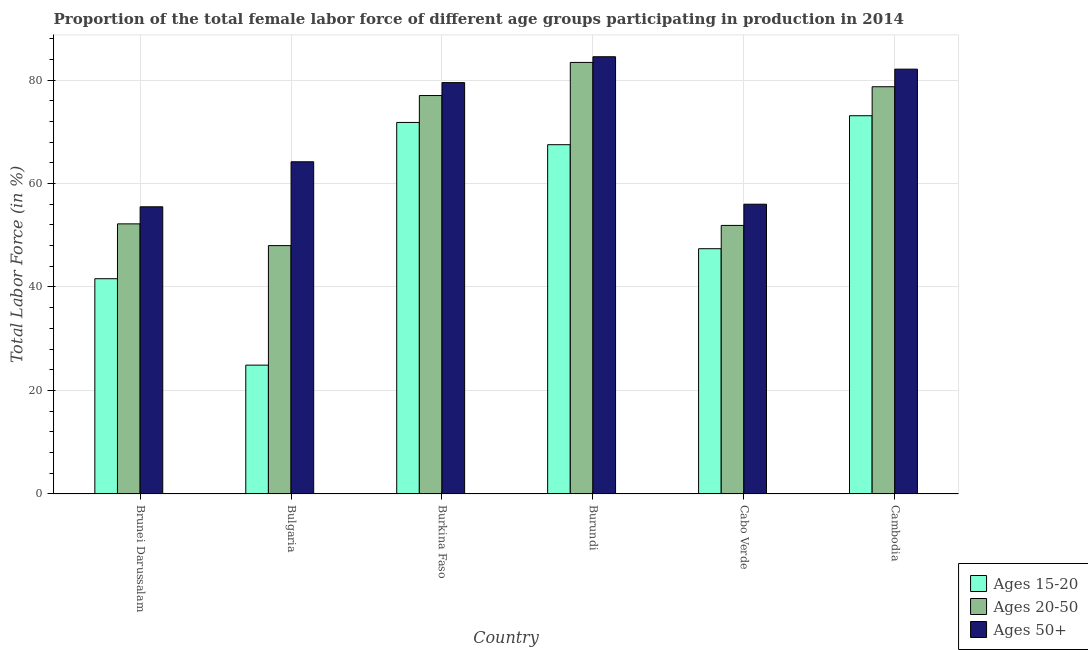How many different coloured bars are there?
Offer a very short reply. 3. Are the number of bars per tick equal to the number of legend labels?
Your response must be concise. Yes. Are the number of bars on each tick of the X-axis equal?
Provide a short and direct response. Yes. How many bars are there on the 6th tick from the left?
Your response must be concise. 3. How many bars are there on the 1st tick from the right?
Keep it short and to the point. 3. In how many cases, is the number of bars for a given country not equal to the number of legend labels?
Provide a succinct answer. 0. What is the percentage of female labor force above age 50 in Brunei Darussalam?
Keep it short and to the point. 55.5. Across all countries, what is the maximum percentage of female labor force within the age group 15-20?
Keep it short and to the point. 73.1. Across all countries, what is the minimum percentage of female labor force within the age group 20-50?
Make the answer very short. 48. In which country was the percentage of female labor force above age 50 maximum?
Keep it short and to the point. Burundi. In which country was the percentage of female labor force within the age group 15-20 minimum?
Offer a very short reply. Bulgaria. What is the total percentage of female labor force above age 50 in the graph?
Provide a succinct answer. 421.8. What is the difference between the percentage of female labor force within the age group 20-50 in Burkina Faso and that in Burundi?
Your answer should be compact. -6.4. What is the difference between the percentage of female labor force within the age group 20-50 in Burkina Faso and the percentage of female labor force within the age group 15-20 in Burundi?
Ensure brevity in your answer.  9.5. What is the average percentage of female labor force within the age group 15-20 per country?
Your answer should be compact. 54.38. What is the ratio of the percentage of female labor force above age 50 in Bulgaria to that in Burkina Faso?
Keep it short and to the point. 0.81. Is the percentage of female labor force above age 50 in Bulgaria less than that in Cambodia?
Ensure brevity in your answer.  Yes. Is the difference between the percentage of female labor force within the age group 15-20 in Bulgaria and Burkina Faso greater than the difference between the percentage of female labor force above age 50 in Bulgaria and Burkina Faso?
Ensure brevity in your answer.  No. What is the difference between the highest and the second highest percentage of female labor force within the age group 20-50?
Provide a short and direct response. 4.7. What is the difference between the highest and the lowest percentage of female labor force within the age group 20-50?
Your answer should be very brief. 35.4. In how many countries, is the percentage of female labor force within the age group 15-20 greater than the average percentage of female labor force within the age group 15-20 taken over all countries?
Your answer should be very brief. 3. Is the sum of the percentage of female labor force above age 50 in Bulgaria and Burkina Faso greater than the maximum percentage of female labor force within the age group 20-50 across all countries?
Provide a succinct answer. Yes. What does the 3rd bar from the left in Brunei Darussalam represents?
Offer a terse response. Ages 50+. What does the 3rd bar from the right in Burkina Faso represents?
Make the answer very short. Ages 15-20. Is it the case that in every country, the sum of the percentage of female labor force within the age group 15-20 and percentage of female labor force within the age group 20-50 is greater than the percentage of female labor force above age 50?
Offer a very short reply. Yes. Are all the bars in the graph horizontal?
Your answer should be compact. No. How many countries are there in the graph?
Your response must be concise. 6. Are the values on the major ticks of Y-axis written in scientific E-notation?
Keep it short and to the point. No. Does the graph contain any zero values?
Keep it short and to the point. No. Where does the legend appear in the graph?
Provide a short and direct response. Bottom right. How are the legend labels stacked?
Your answer should be very brief. Vertical. What is the title of the graph?
Provide a short and direct response. Proportion of the total female labor force of different age groups participating in production in 2014. What is the label or title of the X-axis?
Provide a succinct answer. Country. What is the Total Labor Force (in %) of Ages 15-20 in Brunei Darussalam?
Your response must be concise. 41.6. What is the Total Labor Force (in %) in Ages 20-50 in Brunei Darussalam?
Offer a terse response. 52.2. What is the Total Labor Force (in %) in Ages 50+ in Brunei Darussalam?
Make the answer very short. 55.5. What is the Total Labor Force (in %) of Ages 15-20 in Bulgaria?
Keep it short and to the point. 24.9. What is the Total Labor Force (in %) in Ages 50+ in Bulgaria?
Provide a short and direct response. 64.2. What is the Total Labor Force (in %) of Ages 15-20 in Burkina Faso?
Keep it short and to the point. 71.8. What is the Total Labor Force (in %) of Ages 20-50 in Burkina Faso?
Offer a very short reply. 77. What is the Total Labor Force (in %) in Ages 50+ in Burkina Faso?
Provide a short and direct response. 79.5. What is the Total Labor Force (in %) in Ages 15-20 in Burundi?
Make the answer very short. 67.5. What is the Total Labor Force (in %) of Ages 20-50 in Burundi?
Ensure brevity in your answer.  83.4. What is the Total Labor Force (in %) of Ages 50+ in Burundi?
Provide a short and direct response. 84.5. What is the Total Labor Force (in %) of Ages 15-20 in Cabo Verde?
Provide a short and direct response. 47.4. What is the Total Labor Force (in %) in Ages 20-50 in Cabo Verde?
Give a very brief answer. 51.9. What is the Total Labor Force (in %) of Ages 15-20 in Cambodia?
Make the answer very short. 73.1. What is the Total Labor Force (in %) of Ages 20-50 in Cambodia?
Your answer should be compact. 78.7. What is the Total Labor Force (in %) in Ages 50+ in Cambodia?
Your response must be concise. 82.1. Across all countries, what is the maximum Total Labor Force (in %) in Ages 15-20?
Your answer should be very brief. 73.1. Across all countries, what is the maximum Total Labor Force (in %) of Ages 20-50?
Offer a very short reply. 83.4. Across all countries, what is the maximum Total Labor Force (in %) of Ages 50+?
Provide a short and direct response. 84.5. Across all countries, what is the minimum Total Labor Force (in %) of Ages 15-20?
Provide a short and direct response. 24.9. Across all countries, what is the minimum Total Labor Force (in %) in Ages 20-50?
Your answer should be very brief. 48. Across all countries, what is the minimum Total Labor Force (in %) of Ages 50+?
Give a very brief answer. 55.5. What is the total Total Labor Force (in %) in Ages 15-20 in the graph?
Offer a terse response. 326.3. What is the total Total Labor Force (in %) of Ages 20-50 in the graph?
Ensure brevity in your answer.  391.2. What is the total Total Labor Force (in %) of Ages 50+ in the graph?
Your response must be concise. 421.8. What is the difference between the Total Labor Force (in %) in Ages 20-50 in Brunei Darussalam and that in Bulgaria?
Offer a very short reply. 4.2. What is the difference between the Total Labor Force (in %) of Ages 15-20 in Brunei Darussalam and that in Burkina Faso?
Your response must be concise. -30.2. What is the difference between the Total Labor Force (in %) in Ages 20-50 in Brunei Darussalam and that in Burkina Faso?
Provide a succinct answer. -24.8. What is the difference between the Total Labor Force (in %) of Ages 50+ in Brunei Darussalam and that in Burkina Faso?
Give a very brief answer. -24. What is the difference between the Total Labor Force (in %) in Ages 15-20 in Brunei Darussalam and that in Burundi?
Offer a very short reply. -25.9. What is the difference between the Total Labor Force (in %) in Ages 20-50 in Brunei Darussalam and that in Burundi?
Ensure brevity in your answer.  -31.2. What is the difference between the Total Labor Force (in %) of Ages 50+ in Brunei Darussalam and that in Burundi?
Provide a succinct answer. -29. What is the difference between the Total Labor Force (in %) in Ages 15-20 in Brunei Darussalam and that in Cabo Verde?
Make the answer very short. -5.8. What is the difference between the Total Labor Force (in %) of Ages 50+ in Brunei Darussalam and that in Cabo Verde?
Ensure brevity in your answer.  -0.5. What is the difference between the Total Labor Force (in %) in Ages 15-20 in Brunei Darussalam and that in Cambodia?
Offer a terse response. -31.5. What is the difference between the Total Labor Force (in %) in Ages 20-50 in Brunei Darussalam and that in Cambodia?
Offer a very short reply. -26.5. What is the difference between the Total Labor Force (in %) of Ages 50+ in Brunei Darussalam and that in Cambodia?
Offer a very short reply. -26.6. What is the difference between the Total Labor Force (in %) in Ages 15-20 in Bulgaria and that in Burkina Faso?
Your answer should be very brief. -46.9. What is the difference between the Total Labor Force (in %) in Ages 20-50 in Bulgaria and that in Burkina Faso?
Provide a succinct answer. -29. What is the difference between the Total Labor Force (in %) of Ages 50+ in Bulgaria and that in Burkina Faso?
Provide a succinct answer. -15.3. What is the difference between the Total Labor Force (in %) in Ages 15-20 in Bulgaria and that in Burundi?
Provide a short and direct response. -42.6. What is the difference between the Total Labor Force (in %) of Ages 20-50 in Bulgaria and that in Burundi?
Offer a very short reply. -35.4. What is the difference between the Total Labor Force (in %) of Ages 50+ in Bulgaria and that in Burundi?
Provide a short and direct response. -20.3. What is the difference between the Total Labor Force (in %) in Ages 15-20 in Bulgaria and that in Cabo Verde?
Offer a very short reply. -22.5. What is the difference between the Total Labor Force (in %) of Ages 20-50 in Bulgaria and that in Cabo Verde?
Offer a terse response. -3.9. What is the difference between the Total Labor Force (in %) in Ages 50+ in Bulgaria and that in Cabo Verde?
Your response must be concise. 8.2. What is the difference between the Total Labor Force (in %) in Ages 15-20 in Bulgaria and that in Cambodia?
Keep it short and to the point. -48.2. What is the difference between the Total Labor Force (in %) of Ages 20-50 in Bulgaria and that in Cambodia?
Give a very brief answer. -30.7. What is the difference between the Total Labor Force (in %) of Ages 50+ in Bulgaria and that in Cambodia?
Give a very brief answer. -17.9. What is the difference between the Total Labor Force (in %) of Ages 15-20 in Burkina Faso and that in Burundi?
Give a very brief answer. 4.3. What is the difference between the Total Labor Force (in %) of Ages 20-50 in Burkina Faso and that in Burundi?
Offer a terse response. -6.4. What is the difference between the Total Labor Force (in %) of Ages 50+ in Burkina Faso and that in Burundi?
Give a very brief answer. -5. What is the difference between the Total Labor Force (in %) of Ages 15-20 in Burkina Faso and that in Cabo Verde?
Keep it short and to the point. 24.4. What is the difference between the Total Labor Force (in %) in Ages 20-50 in Burkina Faso and that in Cabo Verde?
Your answer should be compact. 25.1. What is the difference between the Total Labor Force (in %) in Ages 15-20 in Burkina Faso and that in Cambodia?
Keep it short and to the point. -1.3. What is the difference between the Total Labor Force (in %) of Ages 20-50 in Burkina Faso and that in Cambodia?
Your answer should be compact. -1.7. What is the difference between the Total Labor Force (in %) of Ages 15-20 in Burundi and that in Cabo Verde?
Offer a terse response. 20.1. What is the difference between the Total Labor Force (in %) in Ages 20-50 in Burundi and that in Cabo Verde?
Provide a succinct answer. 31.5. What is the difference between the Total Labor Force (in %) of Ages 50+ in Burundi and that in Cabo Verde?
Offer a terse response. 28.5. What is the difference between the Total Labor Force (in %) of Ages 50+ in Burundi and that in Cambodia?
Keep it short and to the point. 2.4. What is the difference between the Total Labor Force (in %) in Ages 15-20 in Cabo Verde and that in Cambodia?
Your answer should be compact. -25.7. What is the difference between the Total Labor Force (in %) in Ages 20-50 in Cabo Verde and that in Cambodia?
Your response must be concise. -26.8. What is the difference between the Total Labor Force (in %) in Ages 50+ in Cabo Verde and that in Cambodia?
Your answer should be very brief. -26.1. What is the difference between the Total Labor Force (in %) in Ages 15-20 in Brunei Darussalam and the Total Labor Force (in %) in Ages 20-50 in Bulgaria?
Offer a terse response. -6.4. What is the difference between the Total Labor Force (in %) of Ages 15-20 in Brunei Darussalam and the Total Labor Force (in %) of Ages 50+ in Bulgaria?
Keep it short and to the point. -22.6. What is the difference between the Total Labor Force (in %) in Ages 20-50 in Brunei Darussalam and the Total Labor Force (in %) in Ages 50+ in Bulgaria?
Ensure brevity in your answer.  -12. What is the difference between the Total Labor Force (in %) in Ages 15-20 in Brunei Darussalam and the Total Labor Force (in %) in Ages 20-50 in Burkina Faso?
Offer a terse response. -35.4. What is the difference between the Total Labor Force (in %) of Ages 15-20 in Brunei Darussalam and the Total Labor Force (in %) of Ages 50+ in Burkina Faso?
Ensure brevity in your answer.  -37.9. What is the difference between the Total Labor Force (in %) of Ages 20-50 in Brunei Darussalam and the Total Labor Force (in %) of Ages 50+ in Burkina Faso?
Give a very brief answer. -27.3. What is the difference between the Total Labor Force (in %) in Ages 15-20 in Brunei Darussalam and the Total Labor Force (in %) in Ages 20-50 in Burundi?
Offer a very short reply. -41.8. What is the difference between the Total Labor Force (in %) in Ages 15-20 in Brunei Darussalam and the Total Labor Force (in %) in Ages 50+ in Burundi?
Give a very brief answer. -42.9. What is the difference between the Total Labor Force (in %) in Ages 20-50 in Brunei Darussalam and the Total Labor Force (in %) in Ages 50+ in Burundi?
Make the answer very short. -32.3. What is the difference between the Total Labor Force (in %) of Ages 15-20 in Brunei Darussalam and the Total Labor Force (in %) of Ages 50+ in Cabo Verde?
Offer a very short reply. -14.4. What is the difference between the Total Labor Force (in %) of Ages 20-50 in Brunei Darussalam and the Total Labor Force (in %) of Ages 50+ in Cabo Verde?
Provide a short and direct response. -3.8. What is the difference between the Total Labor Force (in %) in Ages 15-20 in Brunei Darussalam and the Total Labor Force (in %) in Ages 20-50 in Cambodia?
Provide a short and direct response. -37.1. What is the difference between the Total Labor Force (in %) of Ages 15-20 in Brunei Darussalam and the Total Labor Force (in %) of Ages 50+ in Cambodia?
Your response must be concise. -40.5. What is the difference between the Total Labor Force (in %) of Ages 20-50 in Brunei Darussalam and the Total Labor Force (in %) of Ages 50+ in Cambodia?
Offer a very short reply. -29.9. What is the difference between the Total Labor Force (in %) of Ages 15-20 in Bulgaria and the Total Labor Force (in %) of Ages 20-50 in Burkina Faso?
Make the answer very short. -52.1. What is the difference between the Total Labor Force (in %) of Ages 15-20 in Bulgaria and the Total Labor Force (in %) of Ages 50+ in Burkina Faso?
Ensure brevity in your answer.  -54.6. What is the difference between the Total Labor Force (in %) in Ages 20-50 in Bulgaria and the Total Labor Force (in %) in Ages 50+ in Burkina Faso?
Give a very brief answer. -31.5. What is the difference between the Total Labor Force (in %) of Ages 15-20 in Bulgaria and the Total Labor Force (in %) of Ages 20-50 in Burundi?
Make the answer very short. -58.5. What is the difference between the Total Labor Force (in %) of Ages 15-20 in Bulgaria and the Total Labor Force (in %) of Ages 50+ in Burundi?
Provide a short and direct response. -59.6. What is the difference between the Total Labor Force (in %) of Ages 20-50 in Bulgaria and the Total Labor Force (in %) of Ages 50+ in Burundi?
Provide a succinct answer. -36.5. What is the difference between the Total Labor Force (in %) of Ages 15-20 in Bulgaria and the Total Labor Force (in %) of Ages 50+ in Cabo Verde?
Give a very brief answer. -31.1. What is the difference between the Total Labor Force (in %) of Ages 20-50 in Bulgaria and the Total Labor Force (in %) of Ages 50+ in Cabo Verde?
Ensure brevity in your answer.  -8. What is the difference between the Total Labor Force (in %) in Ages 15-20 in Bulgaria and the Total Labor Force (in %) in Ages 20-50 in Cambodia?
Offer a terse response. -53.8. What is the difference between the Total Labor Force (in %) in Ages 15-20 in Bulgaria and the Total Labor Force (in %) in Ages 50+ in Cambodia?
Make the answer very short. -57.2. What is the difference between the Total Labor Force (in %) of Ages 20-50 in Bulgaria and the Total Labor Force (in %) of Ages 50+ in Cambodia?
Provide a short and direct response. -34.1. What is the difference between the Total Labor Force (in %) of Ages 15-20 in Burkina Faso and the Total Labor Force (in %) of Ages 50+ in Burundi?
Your answer should be very brief. -12.7. What is the difference between the Total Labor Force (in %) of Ages 15-20 in Burkina Faso and the Total Labor Force (in %) of Ages 20-50 in Cabo Verde?
Give a very brief answer. 19.9. What is the difference between the Total Labor Force (in %) in Ages 15-20 in Burkina Faso and the Total Labor Force (in %) in Ages 50+ in Cabo Verde?
Your answer should be compact. 15.8. What is the difference between the Total Labor Force (in %) of Ages 20-50 in Burkina Faso and the Total Labor Force (in %) of Ages 50+ in Cabo Verde?
Your answer should be very brief. 21. What is the difference between the Total Labor Force (in %) of Ages 15-20 in Burkina Faso and the Total Labor Force (in %) of Ages 20-50 in Cambodia?
Offer a very short reply. -6.9. What is the difference between the Total Labor Force (in %) of Ages 20-50 in Burundi and the Total Labor Force (in %) of Ages 50+ in Cabo Verde?
Keep it short and to the point. 27.4. What is the difference between the Total Labor Force (in %) of Ages 15-20 in Burundi and the Total Labor Force (in %) of Ages 20-50 in Cambodia?
Your answer should be very brief. -11.2. What is the difference between the Total Labor Force (in %) of Ages 15-20 in Burundi and the Total Labor Force (in %) of Ages 50+ in Cambodia?
Provide a short and direct response. -14.6. What is the difference between the Total Labor Force (in %) of Ages 15-20 in Cabo Verde and the Total Labor Force (in %) of Ages 20-50 in Cambodia?
Offer a terse response. -31.3. What is the difference between the Total Labor Force (in %) in Ages 15-20 in Cabo Verde and the Total Labor Force (in %) in Ages 50+ in Cambodia?
Your answer should be compact. -34.7. What is the difference between the Total Labor Force (in %) in Ages 20-50 in Cabo Verde and the Total Labor Force (in %) in Ages 50+ in Cambodia?
Provide a short and direct response. -30.2. What is the average Total Labor Force (in %) in Ages 15-20 per country?
Provide a succinct answer. 54.38. What is the average Total Labor Force (in %) in Ages 20-50 per country?
Keep it short and to the point. 65.2. What is the average Total Labor Force (in %) of Ages 50+ per country?
Make the answer very short. 70.3. What is the difference between the Total Labor Force (in %) of Ages 15-20 and Total Labor Force (in %) of Ages 20-50 in Brunei Darussalam?
Your answer should be compact. -10.6. What is the difference between the Total Labor Force (in %) in Ages 15-20 and Total Labor Force (in %) in Ages 50+ in Brunei Darussalam?
Your answer should be very brief. -13.9. What is the difference between the Total Labor Force (in %) in Ages 15-20 and Total Labor Force (in %) in Ages 20-50 in Bulgaria?
Make the answer very short. -23.1. What is the difference between the Total Labor Force (in %) of Ages 15-20 and Total Labor Force (in %) of Ages 50+ in Bulgaria?
Your response must be concise. -39.3. What is the difference between the Total Labor Force (in %) in Ages 20-50 and Total Labor Force (in %) in Ages 50+ in Bulgaria?
Provide a succinct answer. -16.2. What is the difference between the Total Labor Force (in %) of Ages 15-20 and Total Labor Force (in %) of Ages 50+ in Burkina Faso?
Ensure brevity in your answer.  -7.7. What is the difference between the Total Labor Force (in %) of Ages 20-50 and Total Labor Force (in %) of Ages 50+ in Burkina Faso?
Provide a succinct answer. -2.5. What is the difference between the Total Labor Force (in %) in Ages 15-20 and Total Labor Force (in %) in Ages 20-50 in Burundi?
Offer a very short reply. -15.9. What is the difference between the Total Labor Force (in %) in Ages 20-50 and Total Labor Force (in %) in Ages 50+ in Burundi?
Keep it short and to the point. -1.1. What is the difference between the Total Labor Force (in %) of Ages 15-20 and Total Labor Force (in %) of Ages 50+ in Cabo Verde?
Give a very brief answer. -8.6. What is the difference between the Total Labor Force (in %) in Ages 15-20 and Total Labor Force (in %) in Ages 50+ in Cambodia?
Your answer should be compact. -9. What is the ratio of the Total Labor Force (in %) of Ages 15-20 in Brunei Darussalam to that in Bulgaria?
Ensure brevity in your answer.  1.67. What is the ratio of the Total Labor Force (in %) of Ages 20-50 in Brunei Darussalam to that in Bulgaria?
Give a very brief answer. 1.09. What is the ratio of the Total Labor Force (in %) of Ages 50+ in Brunei Darussalam to that in Bulgaria?
Provide a short and direct response. 0.86. What is the ratio of the Total Labor Force (in %) in Ages 15-20 in Brunei Darussalam to that in Burkina Faso?
Your response must be concise. 0.58. What is the ratio of the Total Labor Force (in %) of Ages 20-50 in Brunei Darussalam to that in Burkina Faso?
Offer a terse response. 0.68. What is the ratio of the Total Labor Force (in %) in Ages 50+ in Brunei Darussalam to that in Burkina Faso?
Give a very brief answer. 0.7. What is the ratio of the Total Labor Force (in %) of Ages 15-20 in Brunei Darussalam to that in Burundi?
Ensure brevity in your answer.  0.62. What is the ratio of the Total Labor Force (in %) of Ages 20-50 in Brunei Darussalam to that in Burundi?
Your answer should be compact. 0.63. What is the ratio of the Total Labor Force (in %) in Ages 50+ in Brunei Darussalam to that in Burundi?
Offer a very short reply. 0.66. What is the ratio of the Total Labor Force (in %) of Ages 15-20 in Brunei Darussalam to that in Cabo Verde?
Your answer should be very brief. 0.88. What is the ratio of the Total Labor Force (in %) of Ages 15-20 in Brunei Darussalam to that in Cambodia?
Your answer should be very brief. 0.57. What is the ratio of the Total Labor Force (in %) of Ages 20-50 in Brunei Darussalam to that in Cambodia?
Your answer should be very brief. 0.66. What is the ratio of the Total Labor Force (in %) in Ages 50+ in Brunei Darussalam to that in Cambodia?
Provide a short and direct response. 0.68. What is the ratio of the Total Labor Force (in %) in Ages 15-20 in Bulgaria to that in Burkina Faso?
Offer a very short reply. 0.35. What is the ratio of the Total Labor Force (in %) in Ages 20-50 in Bulgaria to that in Burkina Faso?
Provide a succinct answer. 0.62. What is the ratio of the Total Labor Force (in %) in Ages 50+ in Bulgaria to that in Burkina Faso?
Provide a succinct answer. 0.81. What is the ratio of the Total Labor Force (in %) of Ages 15-20 in Bulgaria to that in Burundi?
Your answer should be very brief. 0.37. What is the ratio of the Total Labor Force (in %) of Ages 20-50 in Bulgaria to that in Burundi?
Make the answer very short. 0.58. What is the ratio of the Total Labor Force (in %) in Ages 50+ in Bulgaria to that in Burundi?
Keep it short and to the point. 0.76. What is the ratio of the Total Labor Force (in %) in Ages 15-20 in Bulgaria to that in Cabo Verde?
Keep it short and to the point. 0.53. What is the ratio of the Total Labor Force (in %) in Ages 20-50 in Bulgaria to that in Cabo Verde?
Offer a terse response. 0.92. What is the ratio of the Total Labor Force (in %) in Ages 50+ in Bulgaria to that in Cabo Verde?
Your response must be concise. 1.15. What is the ratio of the Total Labor Force (in %) in Ages 15-20 in Bulgaria to that in Cambodia?
Provide a succinct answer. 0.34. What is the ratio of the Total Labor Force (in %) of Ages 20-50 in Bulgaria to that in Cambodia?
Offer a terse response. 0.61. What is the ratio of the Total Labor Force (in %) of Ages 50+ in Bulgaria to that in Cambodia?
Your answer should be very brief. 0.78. What is the ratio of the Total Labor Force (in %) of Ages 15-20 in Burkina Faso to that in Burundi?
Your response must be concise. 1.06. What is the ratio of the Total Labor Force (in %) in Ages 20-50 in Burkina Faso to that in Burundi?
Keep it short and to the point. 0.92. What is the ratio of the Total Labor Force (in %) of Ages 50+ in Burkina Faso to that in Burundi?
Give a very brief answer. 0.94. What is the ratio of the Total Labor Force (in %) in Ages 15-20 in Burkina Faso to that in Cabo Verde?
Offer a terse response. 1.51. What is the ratio of the Total Labor Force (in %) of Ages 20-50 in Burkina Faso to that in Cabo Verde?
Ensure brevity in your answer.  1.48. What is the ratio of the Total Labor Force (in %) in Ages 50+ in Burkina Faso to that in Cabo Verde?
Offer a very short reply. 1.42. What is the ratio of the Total Labor Force (in %) in Ages 15-20 in Burkina Faso to that in Cambodia?
Provide a short and direct response. 0.98. What is the ratio of the Total Labor Force (in %) of Ages 20-50 in Burkina Faso to that in Cambodia?
Make the answer very short. 0.98. What is the ratio of the Total Labor Force (in %) in Ages 50+ in Burkina Faso to that in Cambodia?
Provide a succinct answer. 0.97. What is the ratio of the Total Labor Force (in %) of Ages 15-20 in Burundi to that in Cabo Verde?
Offer a very short reply. 1.42. What is the ratio of the Total Labor Force (in %) of Ages 20-50 in Burundi to that in Cabo Verde?
Give a very brief answer. 1.61. What is the ratio of the Total Labor Force (in %) of Ages 50+ in Burundi to that in Cabo Verde?
Your answer should be compact. 1.51. What is the ratio of the Total Labor Force (in %) in Ages 15-20 in Burundi to that in Cambodia?
Give a very brief answer. 0.92. What is the ratio of the Total Labor Force (in %) of Ages 20-50 in Burundi to that in Cambodia?
Provide a short and direct response. 1.06. What is the ratio of the Total Labor Force (in %) of Ages 50+ in Burundi to that in Cambodia?
Your answer should be very brief. 1.03. What is the ratio of the Total Labor Force (in %) of Ages 15-20 in Cabo Verde to that in Cambodia?
Offer a terse response. 0.65. What is the ratio of the Total Labor Force (in %) of Ages 20-50 in Cabo Verde to that in Cambodia?
Provide a short and direct response. 0.66. What is the ratio of the Total Labor Force (in %) of Ages 50+ in Cabo Verde to that in Cambodia?
Ensure brevity in your answer.  0.68. What is the difference between the highest and the second highest Total Labor Force (in %) of Ages 15-20?
Ensure brevity in your answer.  1.3. What is the difference between the highest and the lowest Total Labor Force (in %) of Ages 15-20?
Give a very brief answer. 48.2. What is the difference between the highest and the lowest Total Labor Force (in %) in Ages 20-50?
Give a very brief answer. 35.4. 